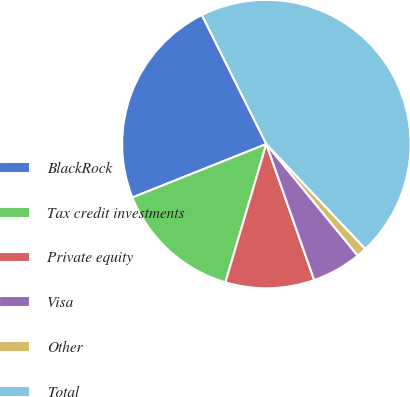Convert chart. <chart><loc_0><loc_0><loc_500><loc_500><pie_chart><fcel>BlackRock<fcel>Tax credit investments<fcel>Private equity<fcel>Visa<fcel>Other<fcel>Total<nl><fcel>23.67%<fcel>14.38%<fcel>9.96%<fcel>5.54%<fcel>1.12%<fcel>45.33%<nl></chart> 